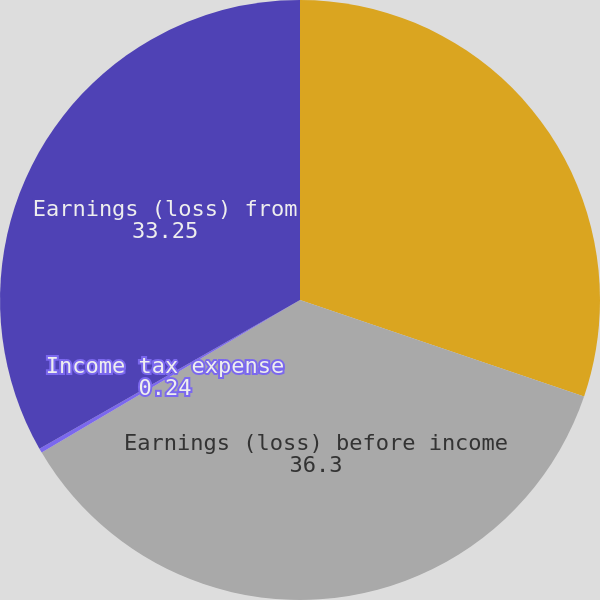<chart> <loc_0><loc_0><loc_500><loc_500><pie_chart><fcel>Gain (loss) on sale of oil and<fcel>Earnings (loss) before income<fcel>Income tax expense<fcel>Earnings (loss) from<nl><fcel>30.21%<fcel>36.3%<fcel>0.24%<fcel>33.25%<nl></chart> 